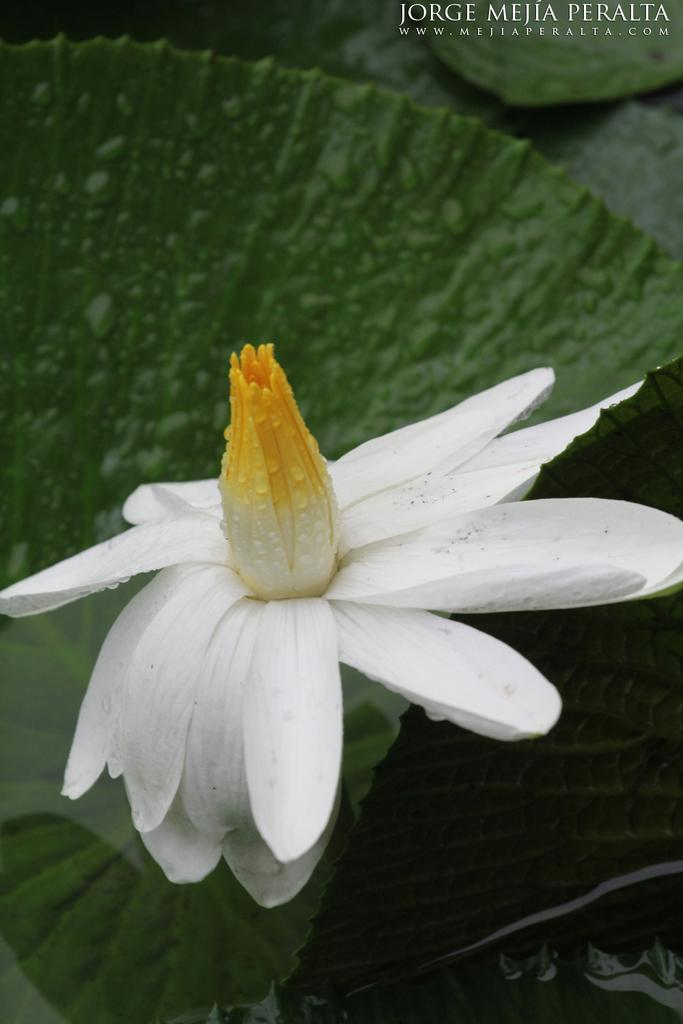What type of plant can be seen in the image? There is a flower in the image. What else is visible in the image besides the flower? There are leaves in the image. Where is the text located in the image? The text is in the top right corner of the image. How many fingers can be seen holding the flower in the image? There are no fingers visible in the image; it only shows a flower and leaves. 